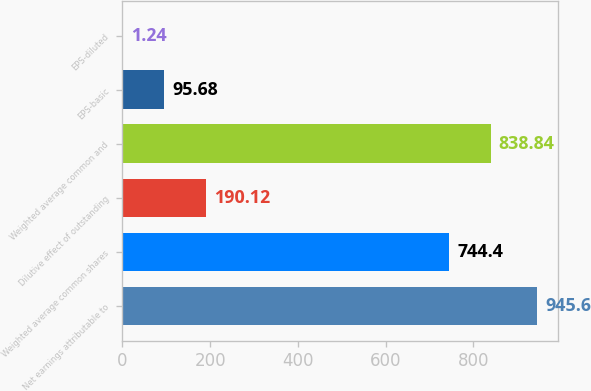Convert chart to OTSL. <chart><loc_0><loc_0><loc_500><loc_500><bar_chart><fcel>Net earnings attributable to<fcel>Weighted average common shares<fcel>Dilutive effect of outstanding<fcel>Weighted average common and<fcel>EPS-basic<fcel>EPS-diluted<nl><fcel>945.6<fcel>744.4<fcel>190.12<fcel>838.84<fcel>95.68<fcel>1.24<nl></chart> 